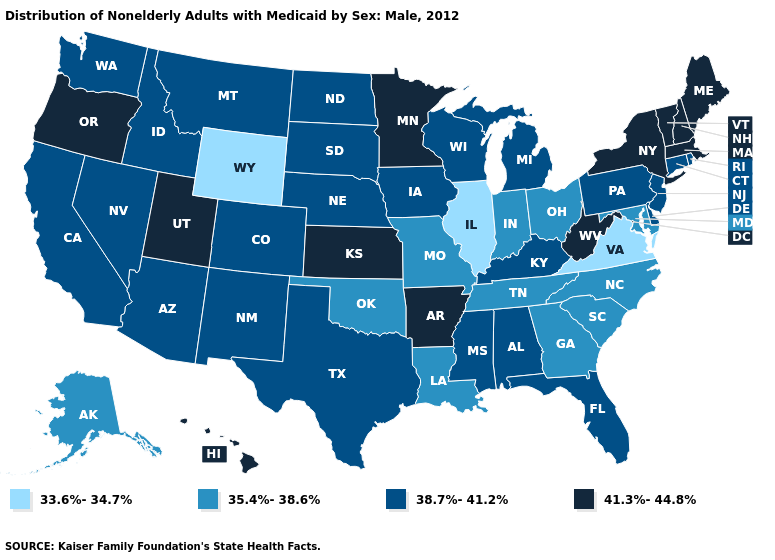Does the map have missing data?
Be succinct. No. Name the states that have a value in the range 35.4%-38.6%?
Give a very brief answer. Alaska, Georgia, Indiana, Louisiana, Maryland, Missouri, North Carolina, Ohio, Oklahoma, South Carolina, Tennessee. What is the value of Texas?
Short answer required. 38.7%-41.2%. Does Virginia have the lowest value in the USA?
Keep it brief. Yes. Name the states that have a value in the range 38.7%-41.2%?
Keep it brief. Alabama, Arizona, California, Colorado, Connecticut, Delaware, Florida, Idaho, Iowa, Kentucky, Michigan, Mississippi, Montana, Nebraska, Nevada, New Jersey, New Mexico, North Dakota, Pennsylvania, Rhode Island, South Dakota, Texas, Washington, Wisconsin. What is the value of Kansas?
Write a very short answer. 41.3%-44.8%. What is the value of Minnesota?
Give a very brief answer. 41.3%-44.8%. What is the value of Rhode Island?
Short answer required. 38.7%-41.2%. Name the states that have a value in the range 41.3%-44.8%?
Short answer required. Arkansas, Hawaii, Kansas, Maine, Massachusetts, Minnesota, New Hampshire, New York, Oregon, Utah, Vermont, West Virginia. What is the value of South Dakota?
Keep it brief. 38.7%-41.2%. Does Nevada have a higher value than New Mexico?
Short answer required. No. Name the states that have a value in the range 35.4%-38.6%?
Answer briefly. Alaska, Georgia, Indiana, Louisiana, Maryland, Missouri, North Carolina, Ohio, Oklahoma, South Carolina, Tennessee. Among the states that border Nebraska , which have the highest value?
Short answer required. Kansas. Does Delaware have the highest value in the South?
Concise answer only. No. What is the highest value in the South ?
Quick response, please. 41.3%-44.8%. 